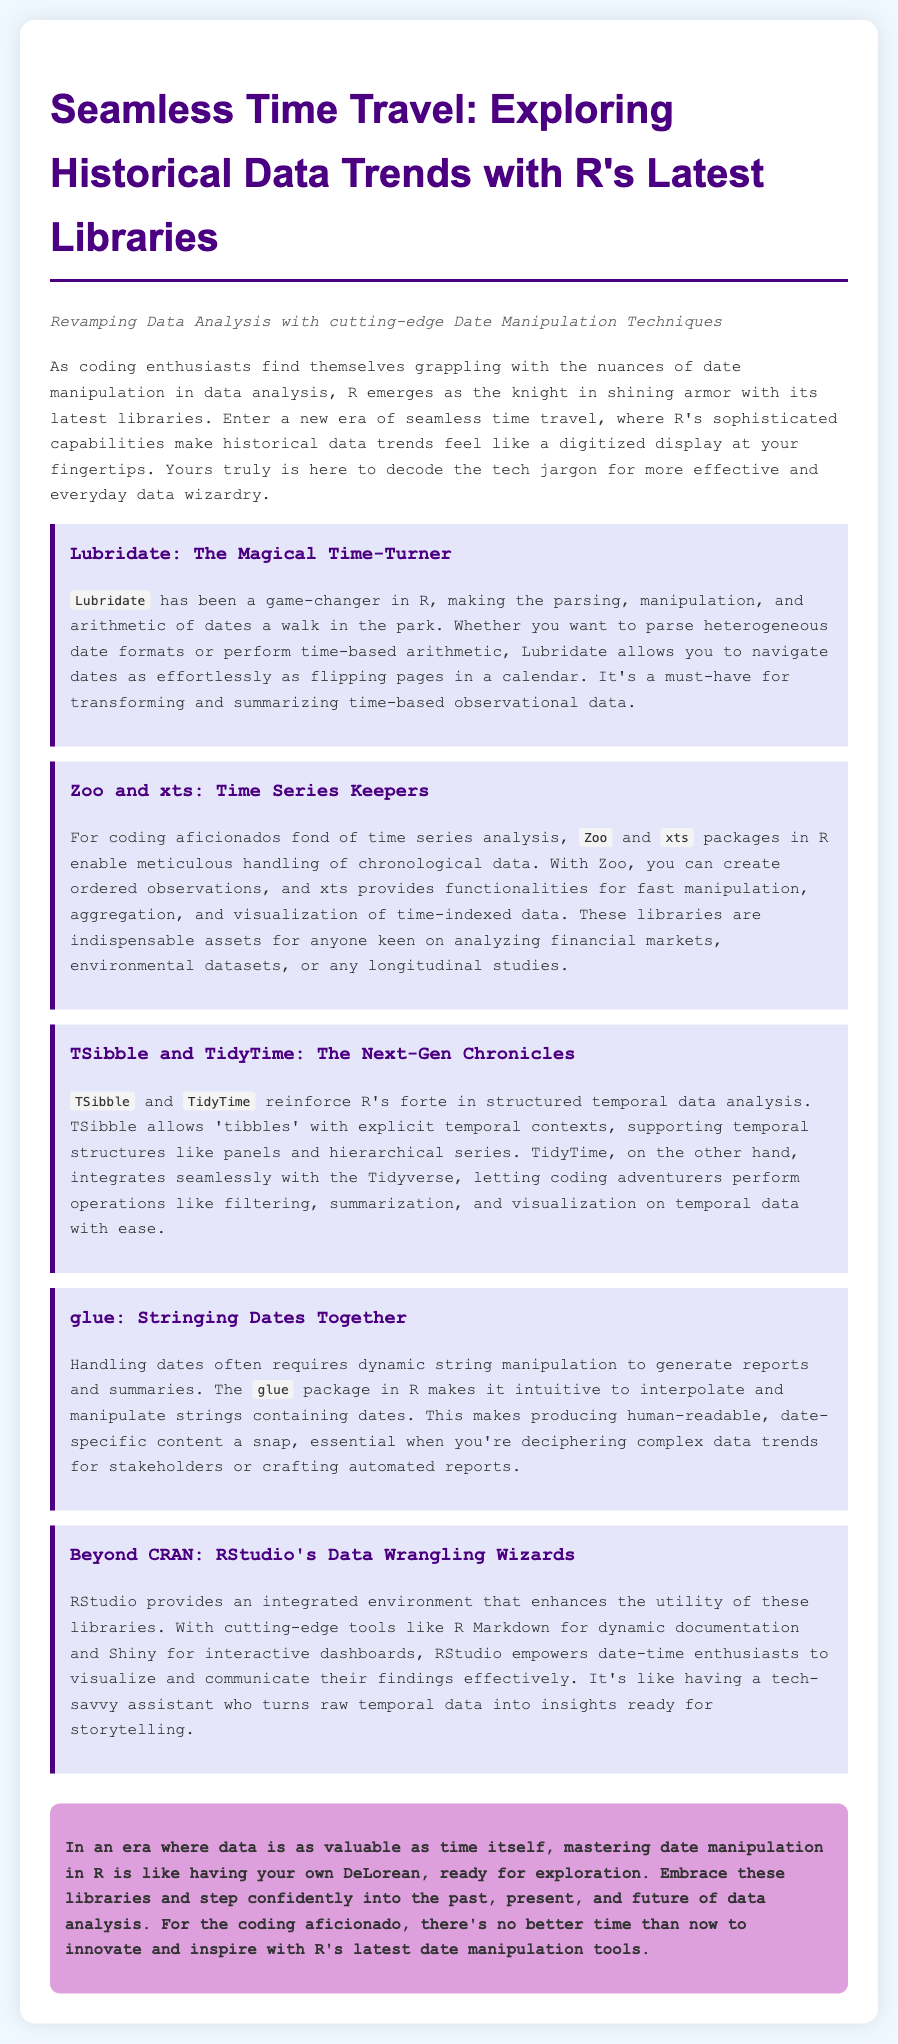What is the title of the press release? The title is the main heading of the document that summarizes its content.
Answer: Seamless Time Travel: Exploring Historical Data Trends with R's Latest Libraries What is the subtitle of the press release? The subtitle provides additional context or thematic focus for the title.
Answer: Revamping Data Analysis with cutting-edge Date Manipulation Techniques What package is referred to as "The Magical Time-Turner"? The question asks for the specific package highlighted in the document known for date manipulation.
Answer: Lubridate Which libraries are mentioned for time series analysis? The question seeks the names of the libraries dedicated to time series data mentioned in the text.
Answer: Zoo and xts What does the TSibble library support? The question inquires about what specific features or contexts are enabled by the TSibble library.
Answer: Temporal structures like panels and hierarchical series Which package is suggested for string manipulation involving dates? This question focuses on a specific package mentioned for its utility in string manipulation related to dates.
Answer: glue What environment enhances the utility of the mentioned libraries? The question asks about the specific environment that boosts the functionality of the R libraries mentioned.
Answer: RStudio What metaphor is used to describe mastering date manipulation in R? The metaphor reflects how the document is framed to compare mastery of data techniques.
Answer: Your own DeLorean 